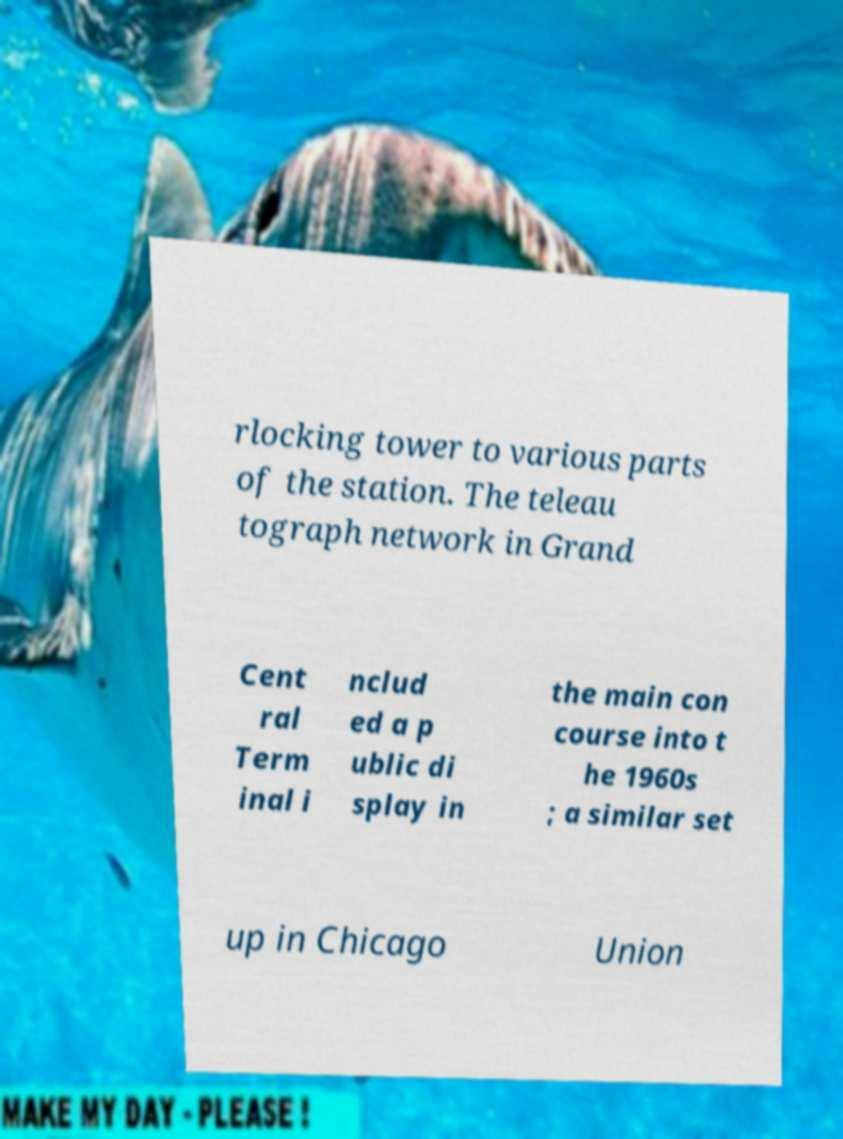Please identify and transcribe the text found in this image. rlocking tower to various parts of the station. The teleau tograph network in Grand Cent ral Term inal i nclud ed a p ublic di splay in the main con course into t he 1960s ; a similar set up in Chicago Union 